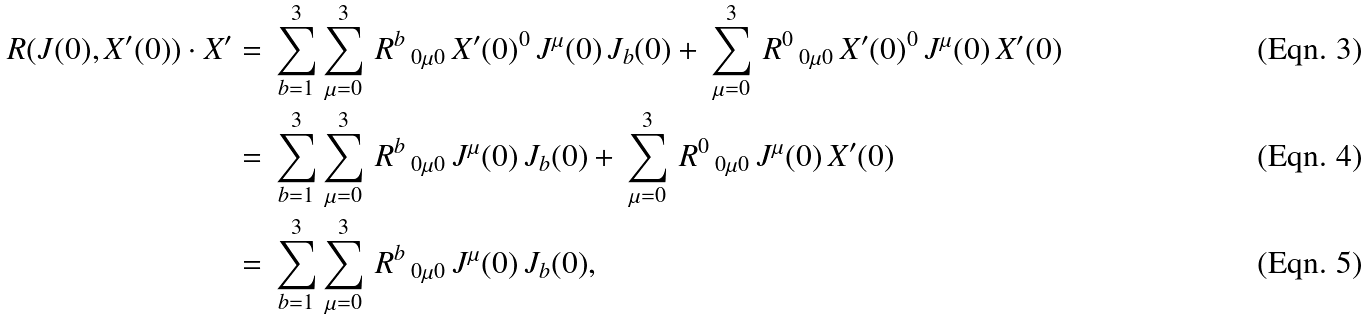Convert formula to latex. <formula><loc_0><loc_0><loc_500><loc_500>R ( J ( 0 ) , X ^ { \prime } ( 0 ) ) \cdot X ^ { \prime } & = \, \sum ^ { 3 } _ { b = 1 } \sum ^ { 3 } _ { \mu = 0 } \, R ^ { b } \, _ { 0 \mu 0 } \, X ^ { \prime } ( 0 ) ^ { 0 } \, J ^ { \mu } ( 0 ) \, J _ { b } ( 0 ) + \, \sum ^ { 3 } _ { \mu = 0 } \, R ^ { 0 } \, _ { 0 \mu 0 } \, X ^ { \prime } ( 0 ) ^ { 0 } \, J ^ { \mu } ( 0 ) \, X ^ { \prime } ( 0 ) \\ & = \, \sum ^ { 3 } _ { b = 1 } \sum ^ { 3 } _ { \mu = 0 } \, R ^ { b } \, _ { 0 \mu 0 } \, J ^ { \mu } ( 0 ) \, J _ { b } ( 0 ) + \, \sum ^ { 3 } _ { \mu = 0 } \, R ^ { 0 } \, _ { 0 \mu 0 } \, J ^ { \mu } ( 0 ) \, X ^ { \prime } ( 0 ) \\ & = \, \sum ^ { 3 } _ { b = 1 } \sum ^ { 3 } _ { \mu = 0 } \, R ^ { b } \, _ { 0 \mu 0 } \, J ^ { \mu } ( 0 ) \, J _ { b } ( 0 ) ,</formula> 